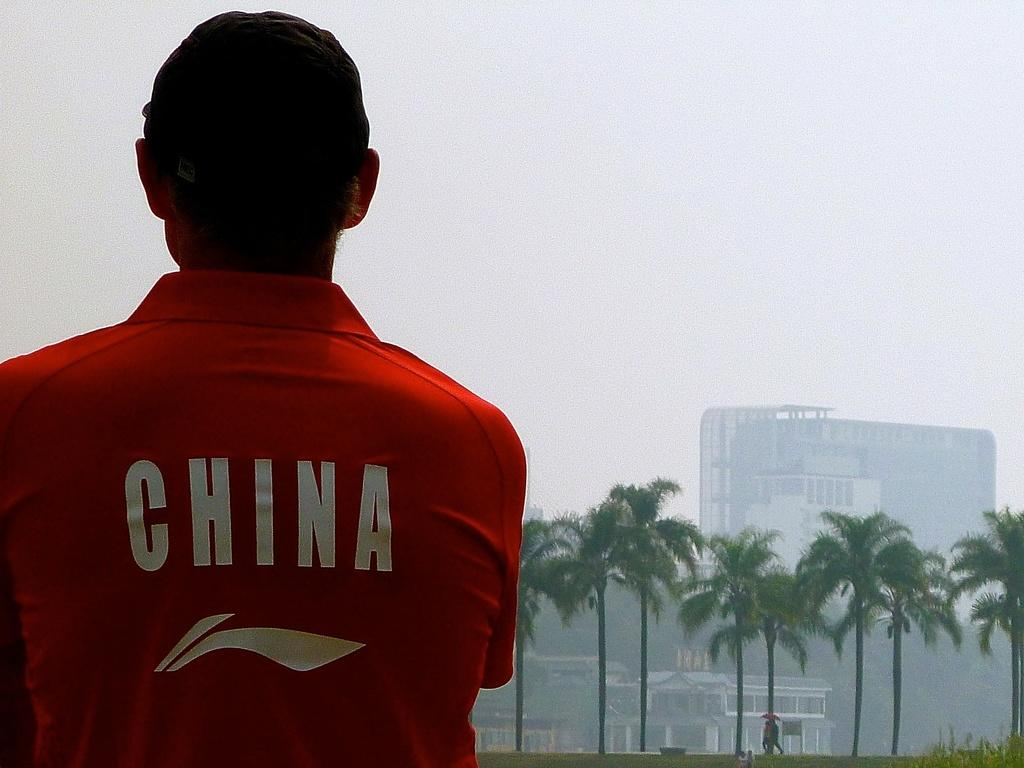Provide a one-sentence caption for the provided image. A man wearing a red China shirt looking at palm trees. 